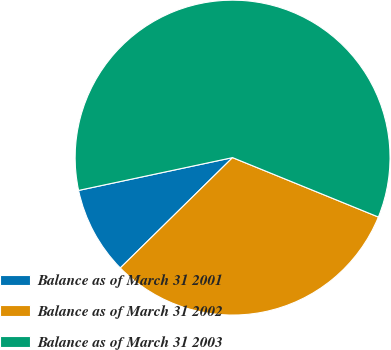<chart> <loc_0><loc_0><loc_500><loc_500><pie_chart><fcel>Balance as of March 31 2001<fcel>Balance as of March 31 2002<fcel>Balance as of March 31 2003<nl><fcel>9.02%<fcel>31.48%<fcel>59.5%<nl></chart> 